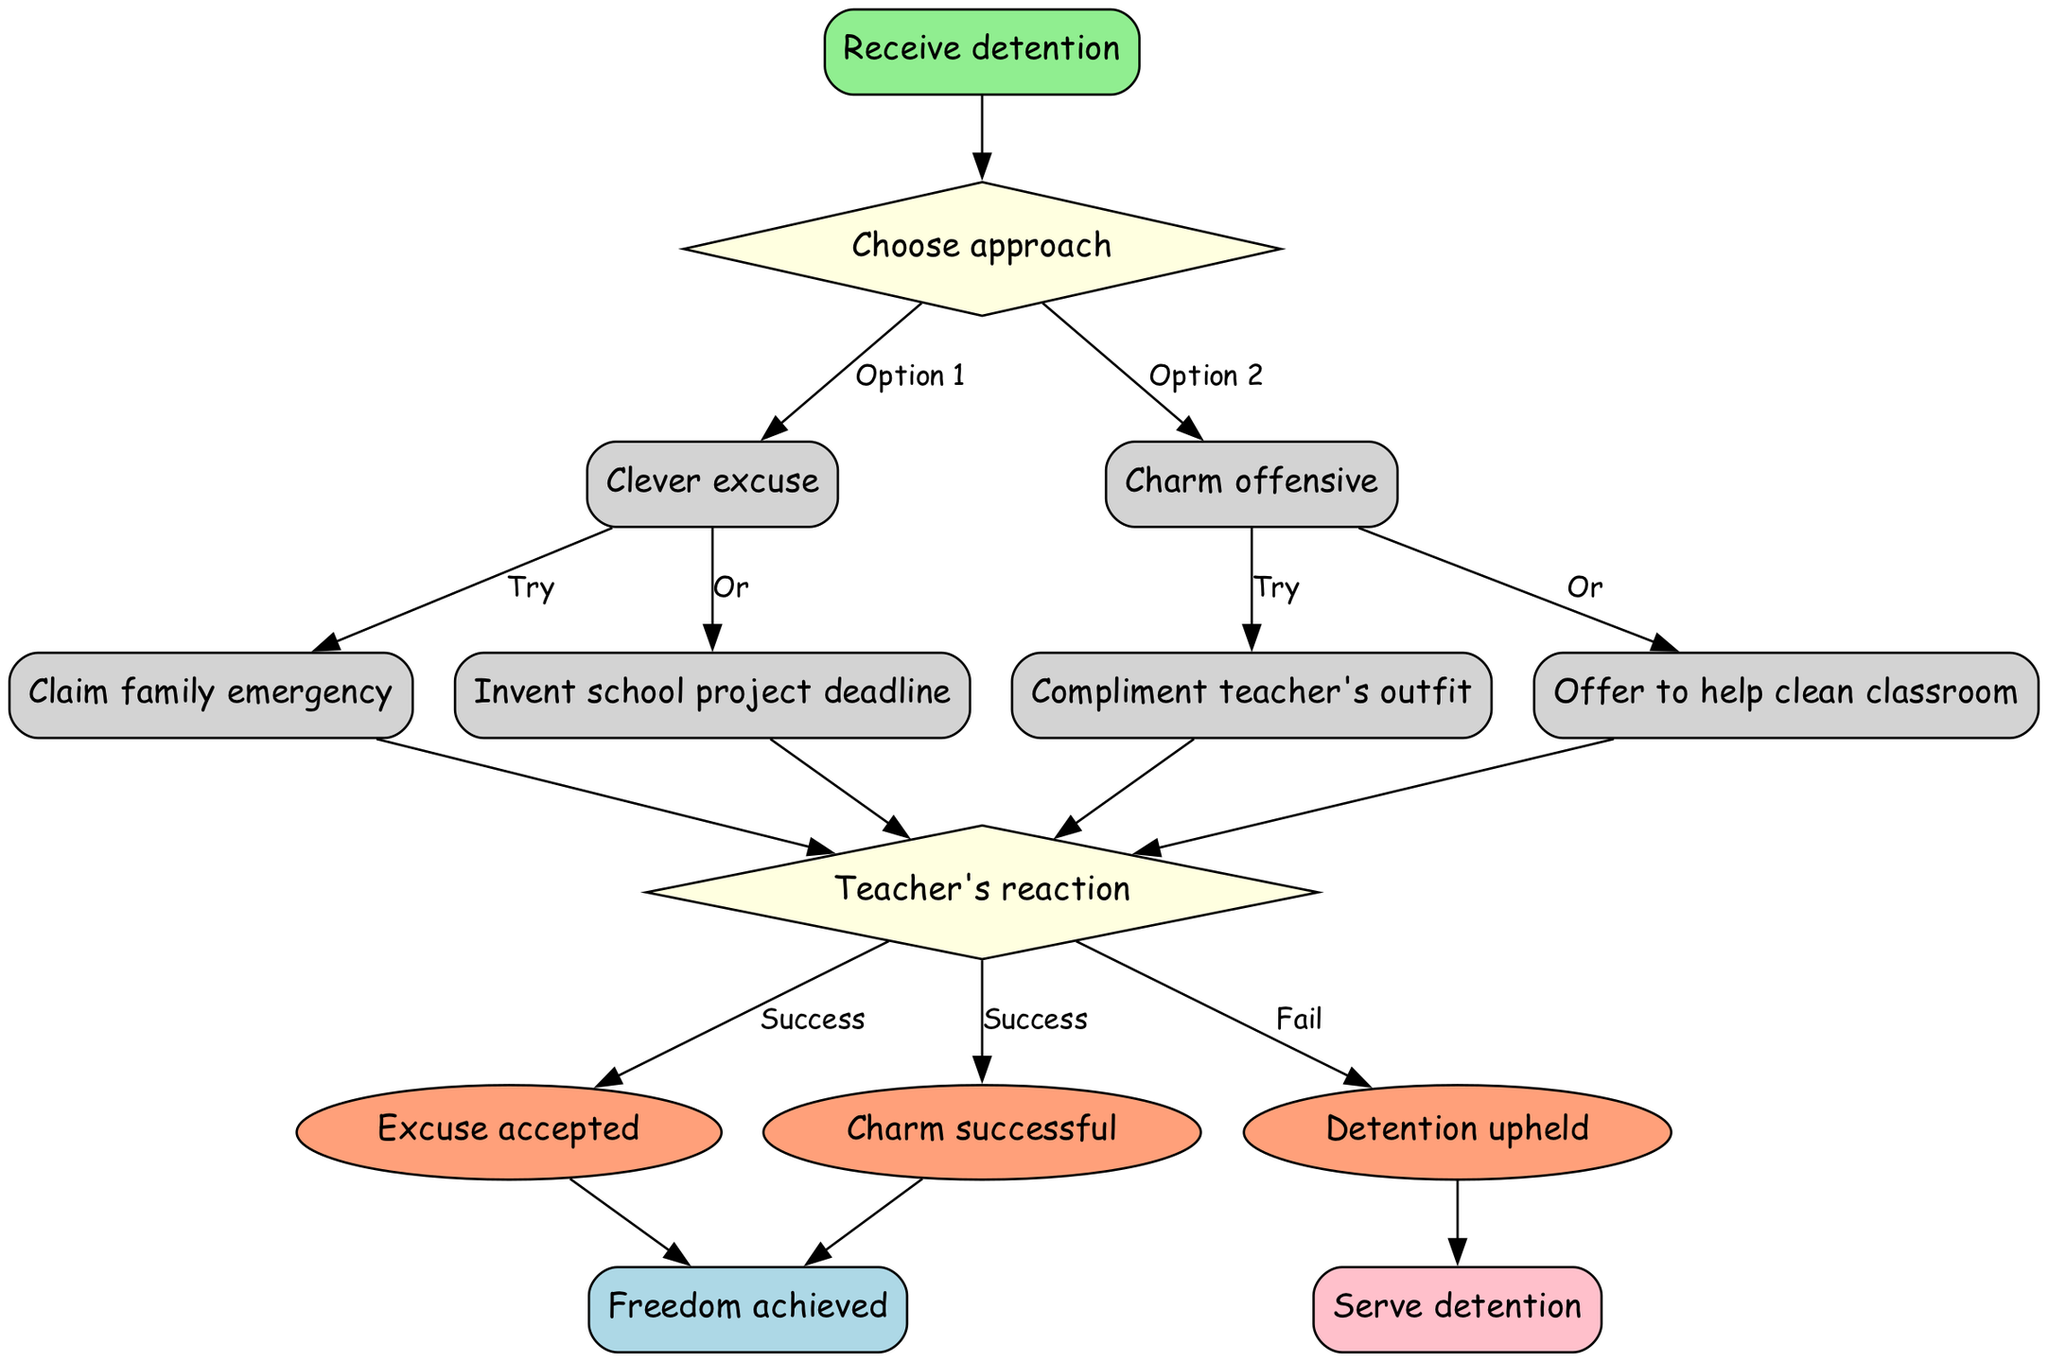What is the initial step in the diagram? The initial step in the flow chart is "Receive detention," which is the starting point for the entire process.
Answer: Receive detention How many options are available for the first decision? The first decision node offers two options: "Clever excuse" and "Charm offensive." Counting these gives a total of two options.
Answer: 2 What is one action under the "Clever excuse" option? One action listed under "Clever excuse" is "Claim family emergency," which represents a possible excuse to avoid detention.
Answer: Claim family emergency Which outcome leads to serving detention? The outcome that leads to serving detention is "Detention upheld," which occurs if the teacher does not accept the excuses or charm efforts.
Answer: Detention upheld If the "Charm offensive" is chosen, what is one possible action? If "Charm offensive" is chosen, one possible action is "Compliment teacher's outfit," which is a way to use charm to persuade the teacher.
Answer: Compliment teacher's outfit What must happen after an action is taken? After any action is taken (from either option), the next step is determining the "Teacher's reaction," which is a decision point that influences the outcomes.
Answer: Teacher's reaction How many outcomes are there in total? There are three outcomes listed: "Excuse accepted," "Charm successful," and "Detention upheld," which total three distinct outcomes.
Answer: 3 Which option requires trying to invent a school project deadline? The action "Invent school project deadline" is associated with the "Clever excuse" option, indicating it’s one of the methods to escape detention under this approach.
Answer: Clever excuse 